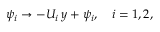<formula> <loc_0><loc_0><loc_500><loc_500>\psi _ { i } \rightarrow - U _ { i } \, y + \psi _ { i } , \quad i = 1 , 2 ,</formula> 